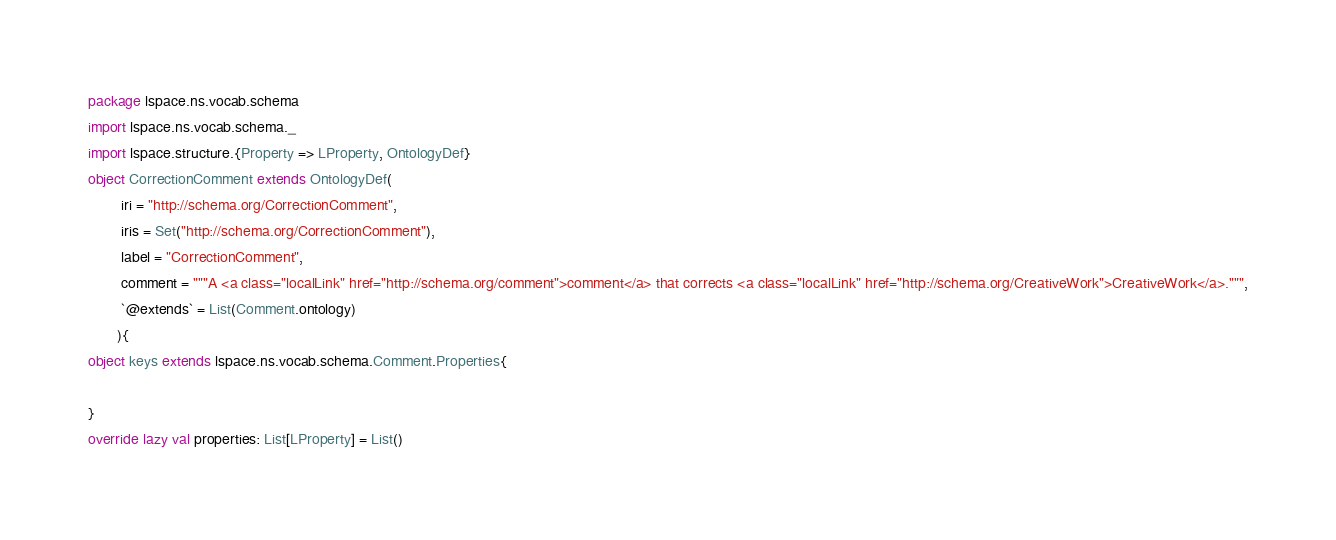<code> <loc_0><loc_0><loc_500><loc_500><_Scala_>package lspace.ns.vocab.schema
import lspace.ns.vocab.schema._
import lspace.structure.{Property => LProperty, OntologyDef}
object CorrectionComment extends OntologyDef(
        iri = "http://schema.org/CorrectionComment",
        iris = Set("http://schema.org/CorrectionComment"),
        label = "CorrectionComment",
        comment = """A <a class="localLink" href="http://schema.org/comment">comment</a> that corrects <a class="localLink" href="http://schema.org/CreativeWork">CreativeWork</a>.""",
        `@extends` = List(Comment.ontology)
       ){
object keys extends lspace.ns.vocab.schema.Comment.Properties{

}
override lazy val properties: List[LProperty] = List()</code> 